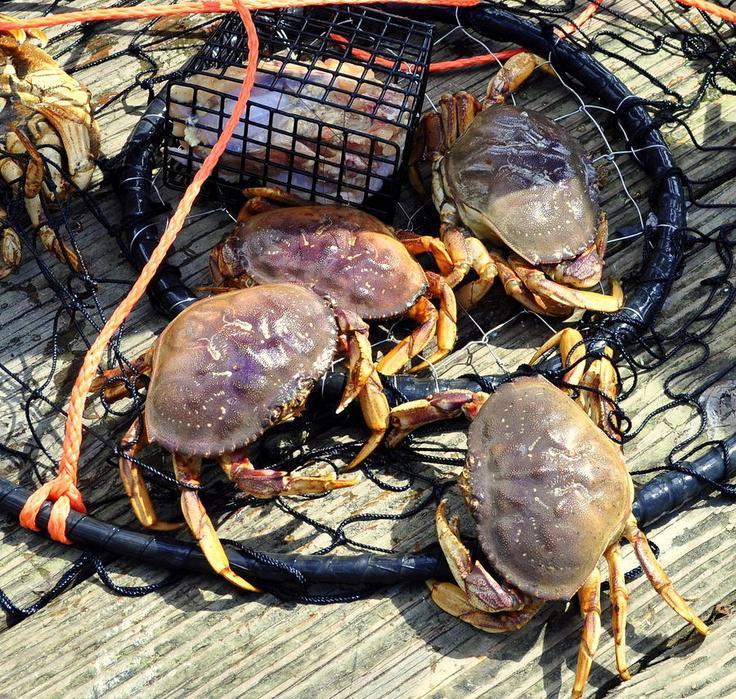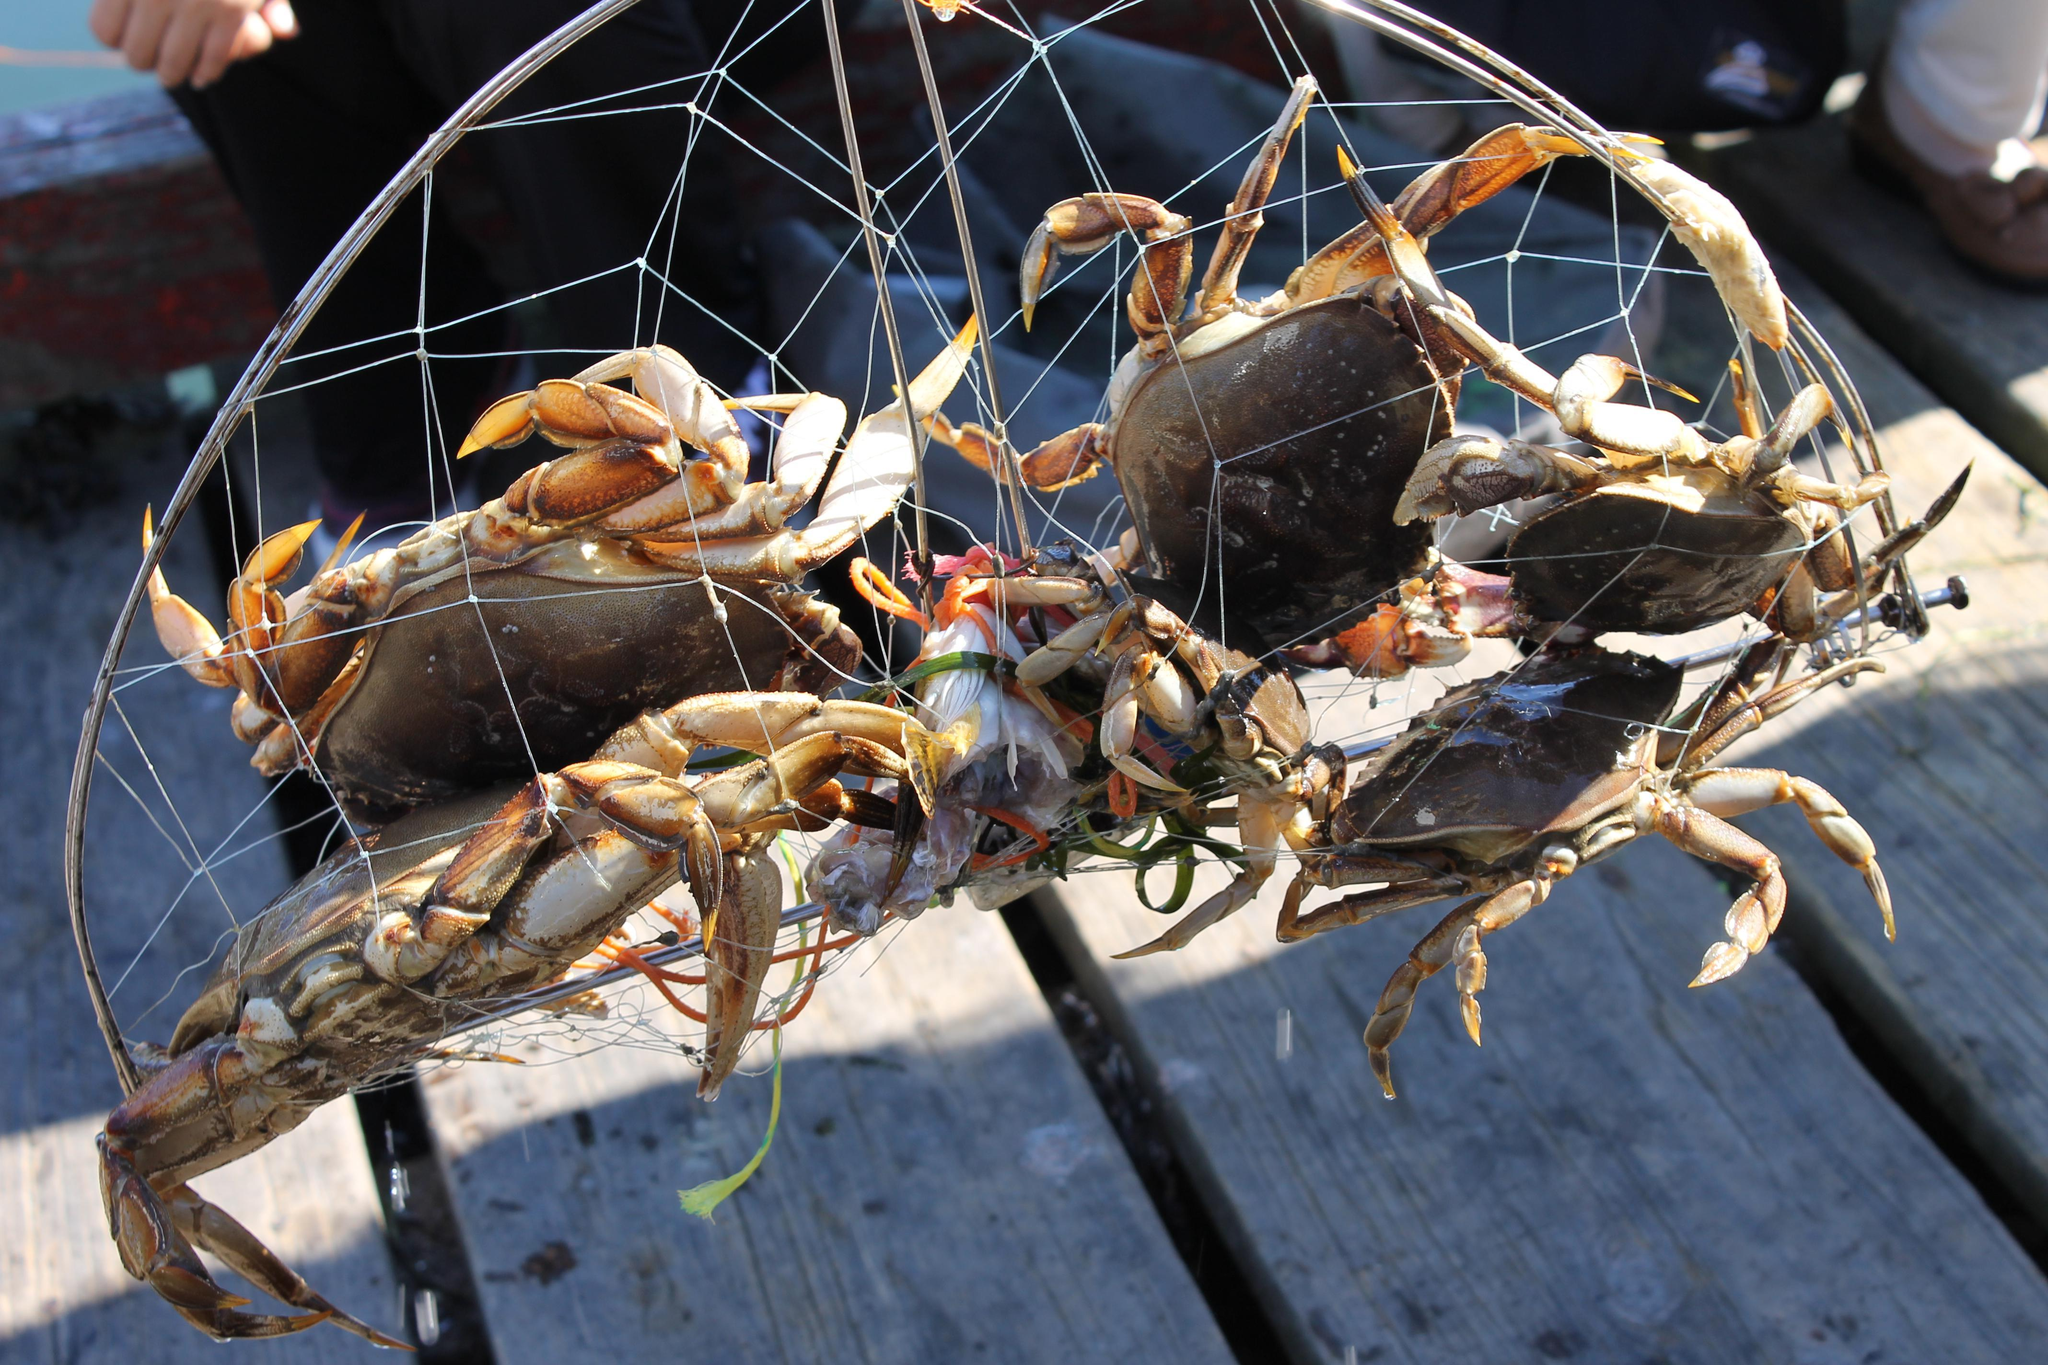The first image is the image on the left, the second image is the image on the right. Assess this claim about the two images: "Each image shows purplish-gray crabs in a container made of mesh attached to a frame.". Correct or not? Answer yes or no. Yes. The first image is the image on the left, the second image is the image on the right. For the images shown, is this caption "At least one crab is in the wild." true? Answer yes or no. No. 